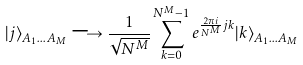Convert formula to latex. <formula><loc_0><loc_0><loc_500><loc_500>| j \rangle _ { A _ { 1 } \dots A _ { M } } \longrightarrow \frac { 1 } { \sqrt { N ^ { M } } } \sum _ { k = 0 } ^ { N ^ { M } - 1 } e ^ { \frac { 2 \pi i } { N ^ { M } } j k } | k \rangle _ { A _ { 1 } \dots A _ { M } }</formula> 